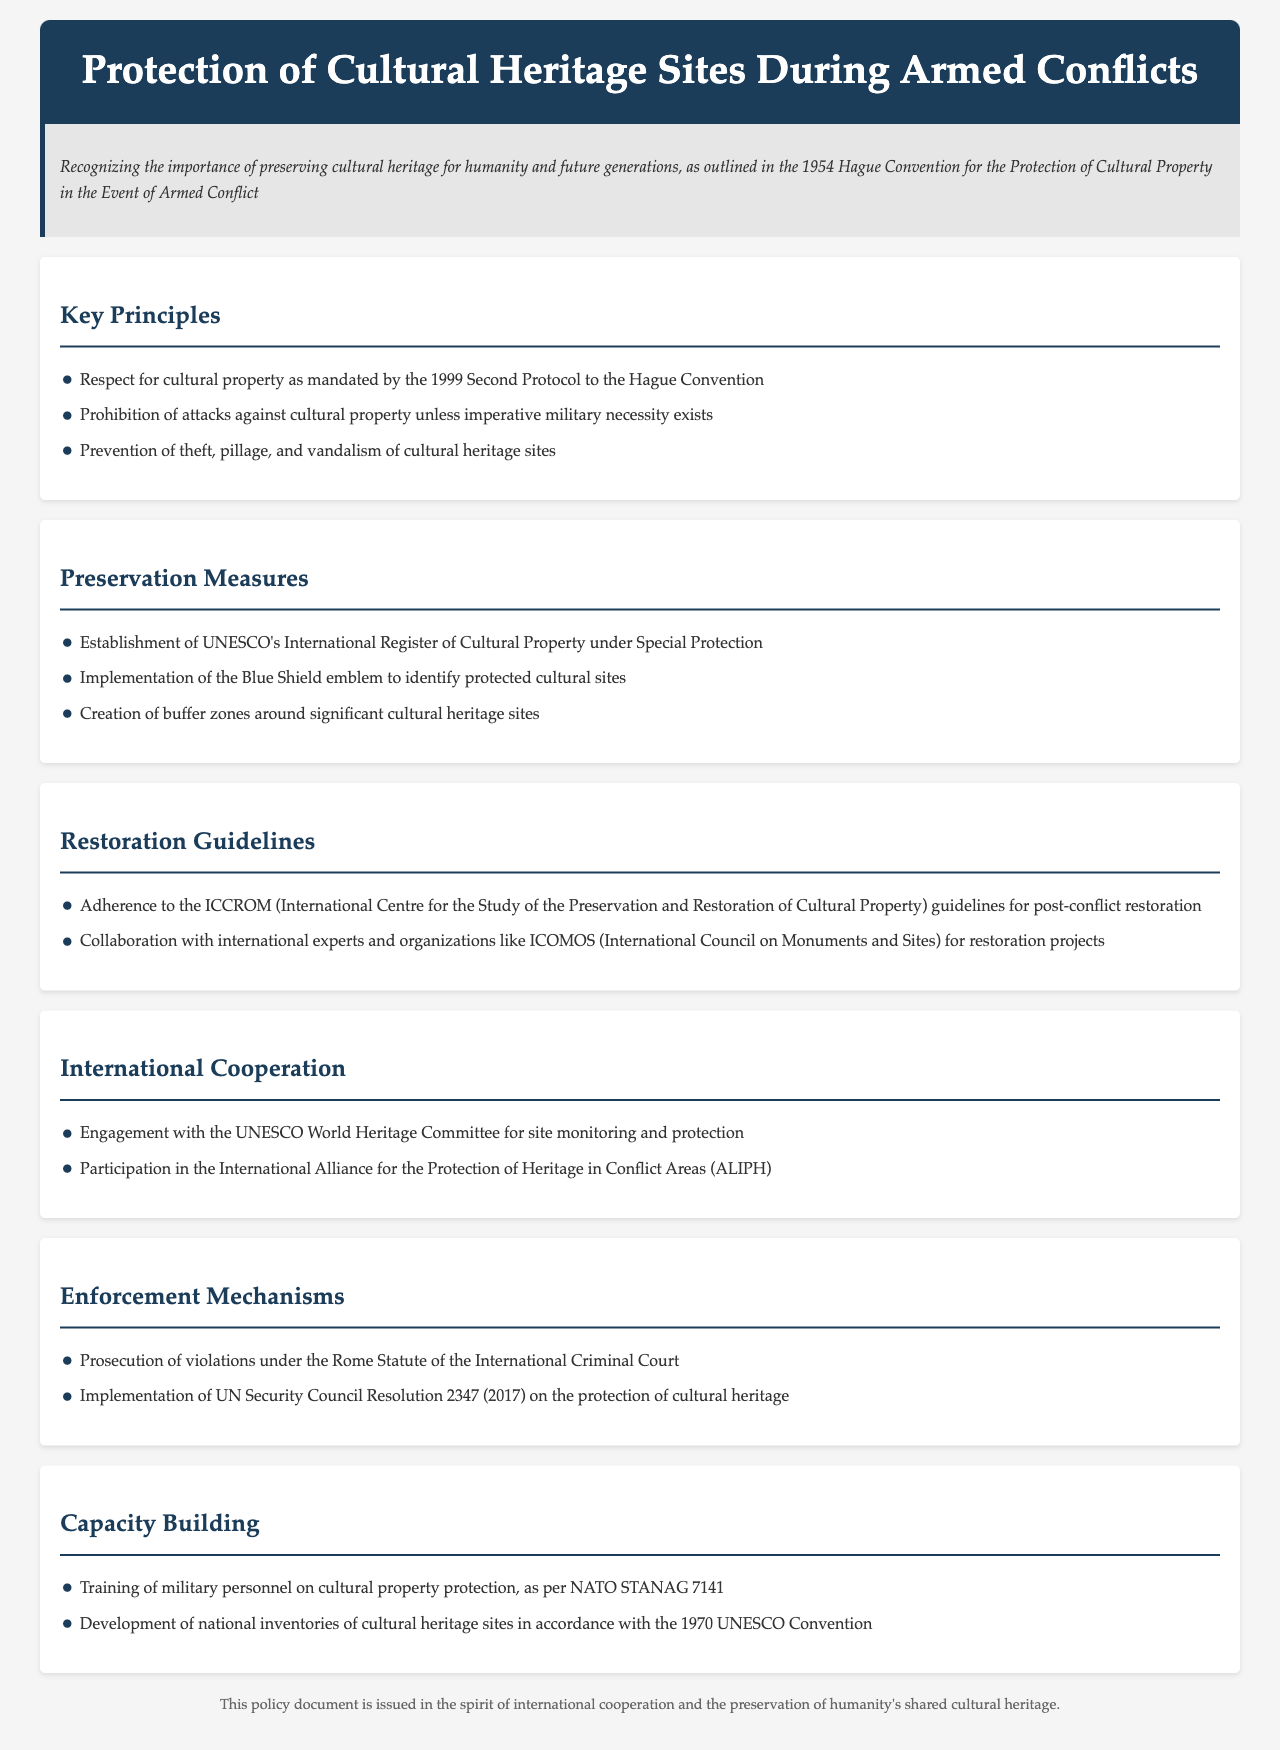What is the main treaty recognized for the protection of cultural heritage? The document recognizes the 1954 Hague Convention for the Protection of Cultural Property in the Event of Armed Conflict as the main treaty.
Answer: 1954 Hague Convention What emblem is implemented to identify protected cultural sites? The document mentions the implementation of the Blue Shield emblem.
Answer: Blue Shield Which international center's guidelines must be adhered to for post-conflict restoration? The guidelines of the International Centre for the Study of the Preservation and Restoration of Cultural Property (ICCROM) must be adhered to.
Answer: ICCROM What resolution is mentioned for the implementation related to cultural heritage protection? The document refers to UN Security Council Resolution 2347 (2017) concerning the protection of cultural heritage.
Answer: Resolution 2347 Which organization is involved in monitoring and protecting cultural sites? The UNESCO World Heritage Committee is mentioned as an organization engaged in site monitoring and protection.
Answer: UNESCO World Heritage Committee What type of measures are established for cultural heritage sites? The document outlines preservation measures for cultural heritage sites.
Answer: Preservation measures What is a requirement for military personnel as per the policy? Training of military personnel on cultural property protection is a requirement as stated in the document.
Answer: Training of military personnel Which international alliance is mentioned for protecting heritage in conflict areas? The International Alliance for the Protection of Heritage in Conflict Areas (ALIPH) is noted in the document.
Answer: ALIPH What is emphasized regarding theft and vandalism in cultural heritage sites? The document emphasizes the prevention of theft, pillage, and vandalism of cultural heritage sites.
Answer: Prevention of theft, pillage, and vandalism 